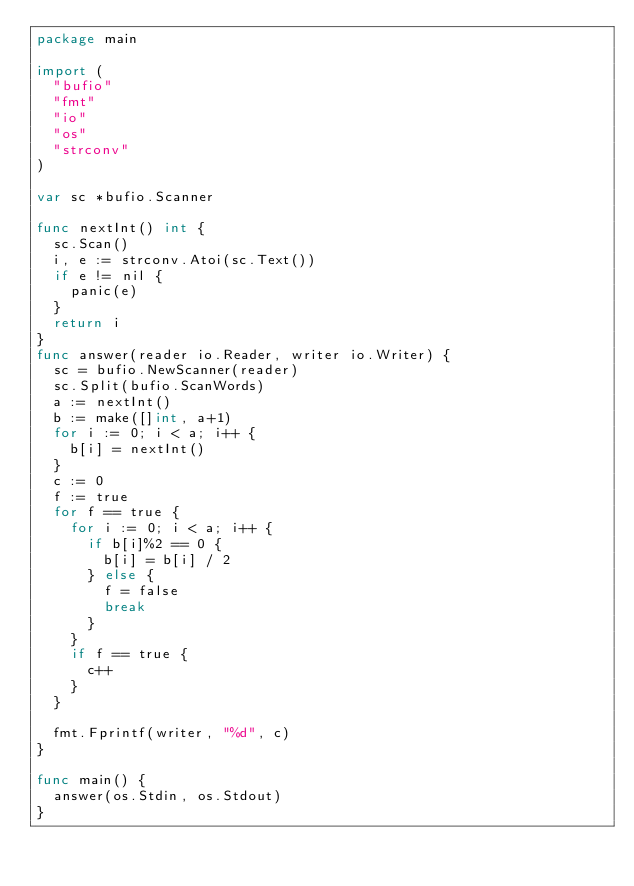Convert code to text. <code><loc_0><loc_0><loc_500><loc_500><_Go_>package main

import (
	"bufio"
	"fmt"
	"io"
	"os"
	"strconv"
)

var sc *bufio.Scanner

func nextInt() int {
	sc.Scan()
	i, e := strconv.Atoi(sc.Text())
	if e != nil {
		panic(e)
	}
	return i
}
func answer(reader io.Reader, writer io.Writer) {
	sc = bufio.NewScanner(reader)
	sc.Split(bufio.ScanWords)
	a := nextInt()
	b := make([]int, a+1)
	for i := 0; i < a; i++ {
		b[i] = nextInt()
	}
	c := 0
	f := true
	for f == true {
		for i := 0; i < a; i++ {
			if b[i]%2 == 0 {
				b[i] = b[i] / 2
			} else {
				f = false
				break
			}
		}
		if f == true {
			c++
		}
	}

	fmt.Fprintf(writer, "%d", c)
}

func main() {
	answer(os.Stdin, os.Stdout)
}
</code> 